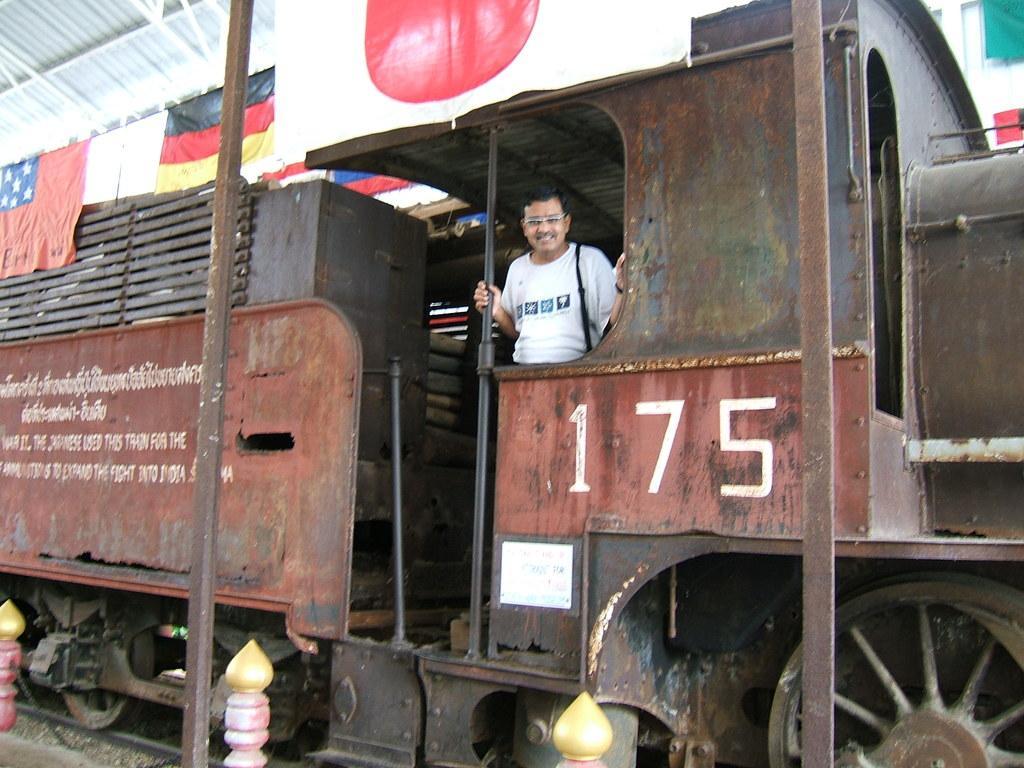How would you summarize this image in a sentence or two? In this picture there is a train in the center of the image and there is a person inside it, there are flags and a roof at the top side of the image and there is a building in the top right side of the image, there is a pole on the left side of the image. 